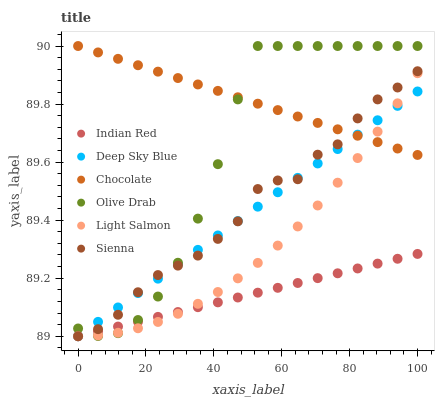Does Indian Red have the minimum area under the curve?
Answer yes or no. Yes. Does Chocolate have the maximum area under the curve?
Answer yes or no. Yes. Does Chocolate have the minimum area under the curve?
Answer yes or no. No. Does Indian Red have the maximum area under the curve?
Answer yes or no. No. Is Chocolate the smoothest?
Answer yes or no. Yes. Is Sienna the roughest?
Answer yes or no. Yes. Is Indian Red the smoothest?
Answer yes or no. No. Is Indian Red the roughest?
Answer yes or no. No. Does Indian Red have the lowest value?
Answer yes or no. Yes. Does Chocolate have the lowest value?
Answer yes or no. No. Does Olive Drab have the highest value?
Answer yes or no. Yes. Does Indian Red have the highest value?
Answer yes or no. No. Is Indian Red less than Chocolate?
Answer yes or no. Yes. Is Chocolate greater than Indian Red?
Answer yes or no. Yes. Does Sienna intersect Chocolate?
Answer yes or no. Yes. Is Sienna less than Chocolate?
Answer yes or no. No. Is Sienna greater than Chocolate?
Answer yes or no. No. Does Indian Red intersect Chocolate?
Answer yes or no. No. 